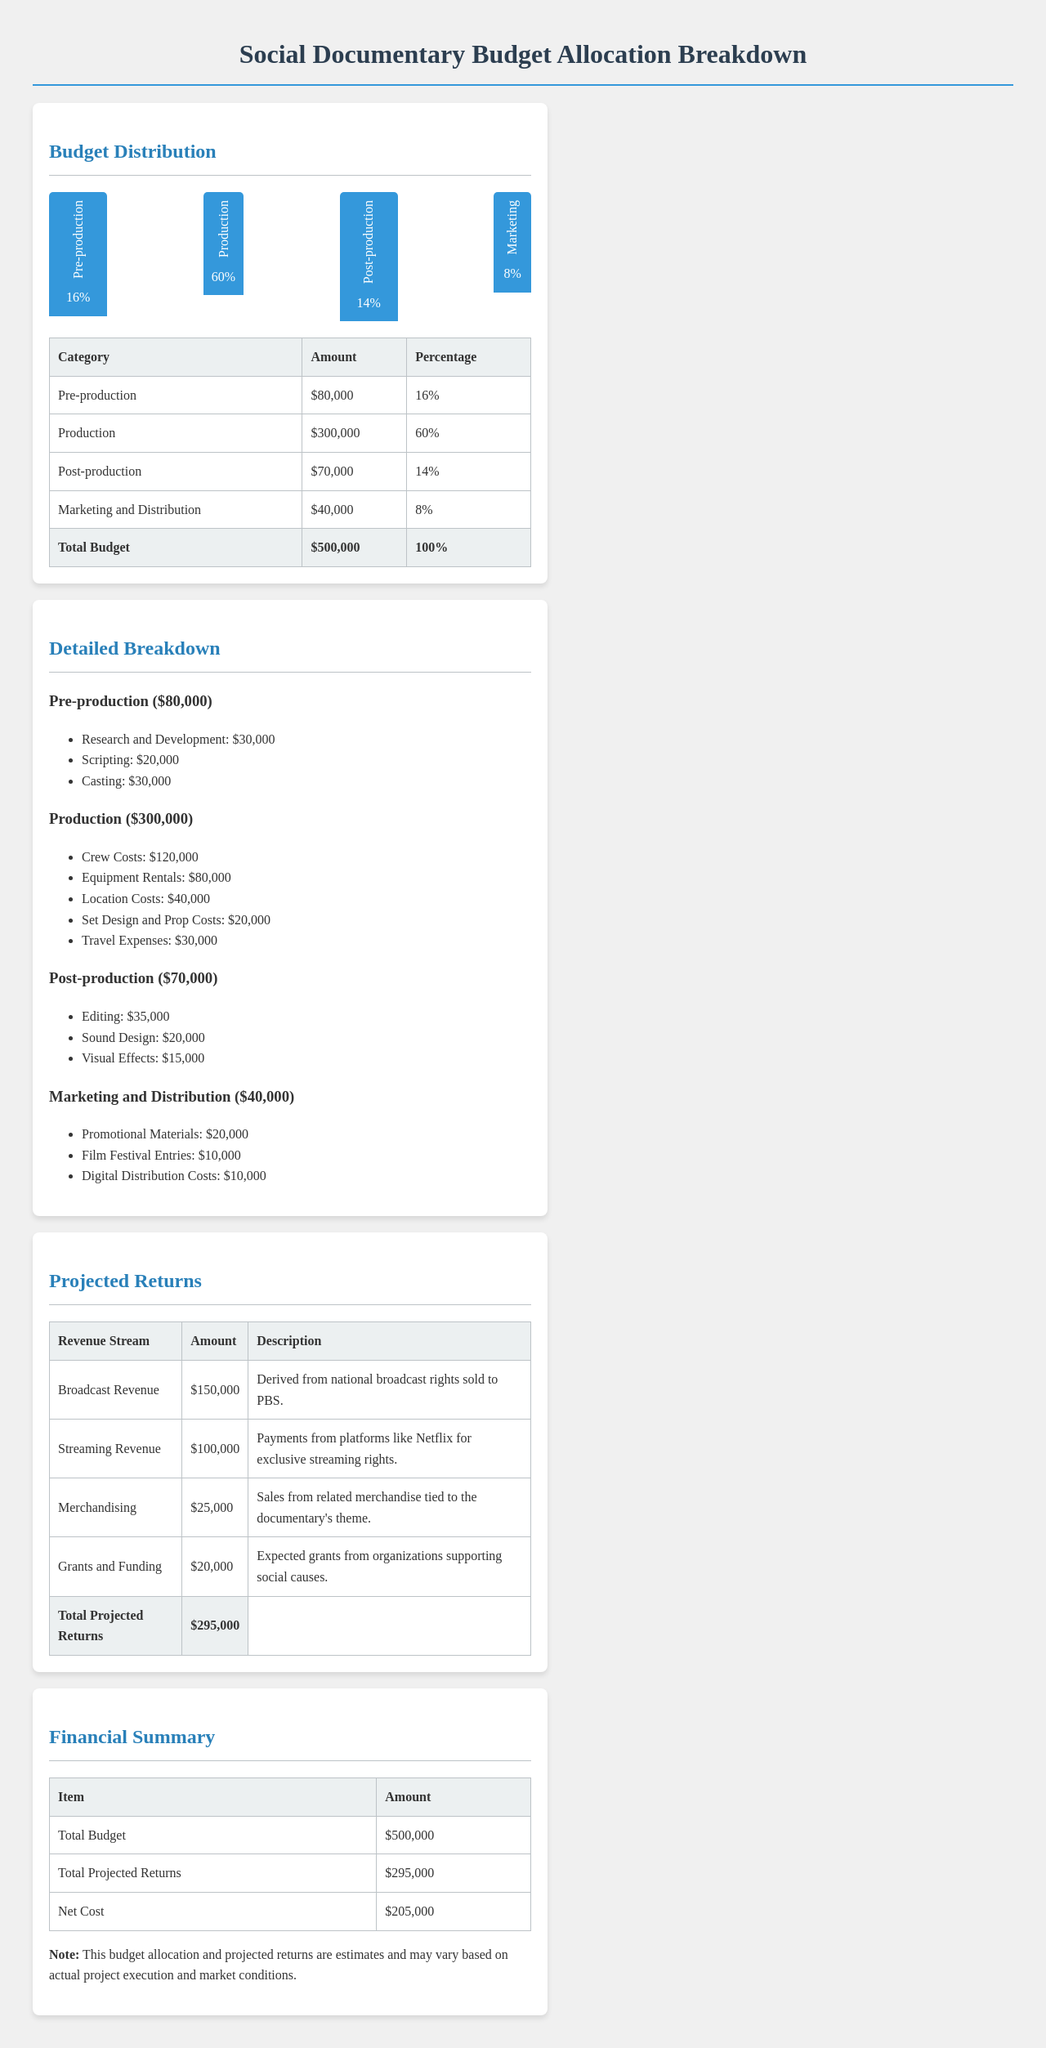What is the total budget? The total budget is provided at the end of the budget distribution section.
Answer: $500,000 What percentage of the budget is allocated to production? The document specifies the percentage allocated to production in the budget distribution section.
Answer: 60% How much is allocated for post-production? The amount allocated for post-production is detailed in the budget distribution table.
Answer: $70,000 What is the revenue from streaming? The revenue from streaming is listed in the projected returns table of the document.
Answer: $100,000 What are the total projected returns? The total projected returns are found at the bottom of the projected returns table.
Answer: $295,000 What is the net cost? The net cost is calculated from the total budget and total projected returns detailed in the financial summary table.
Answer: $205,000 How much is allocated for marketing and distribution? The allocation for marketing and distribution is mentioned in the budget distribution table.
Answer: $40,000 What is the highest individual cost in production? The individual costs in production can be found in the detailed breakdown section.
Answer: $120,000 What is the total amount for grants and funding? The amount for grants and funding is specified in the projected returns section.
Answer: $20,000 What percentage is allocated for pre-production? The percentage allocated for pre-production is indicated in the budget distribution chart.
Answer: 16% 